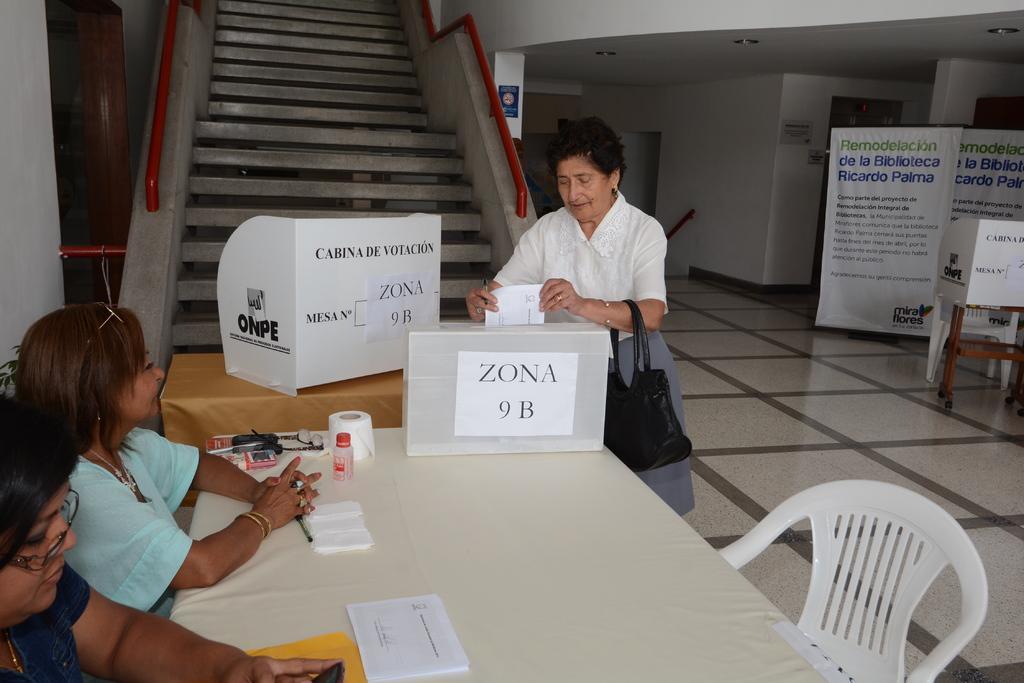Could you give a brief overview of what you see in this image? In this picture we can see a woman carrying her bag standing on a floor dropping paper into the box and here on table we can see some bottle,tissue papers, spectacle, cards and aside to this table we have two woman sitting on chairs and here we can see steps aside to this steps we have wall and grill to hold and in background we can see banners. 